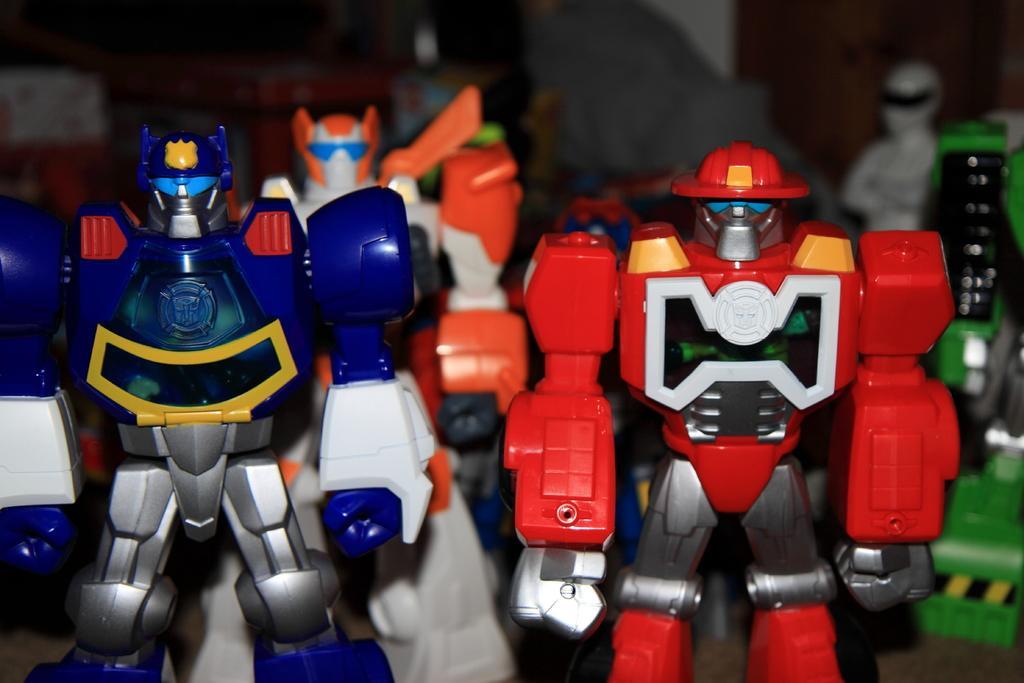How would you summarize this image in a sentence or two? In this image, I can see the robot toys with different colors. The background looks blurry. 